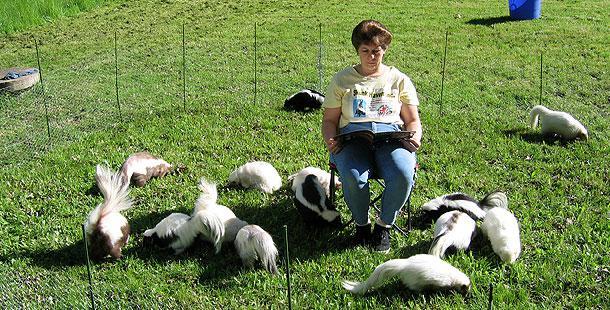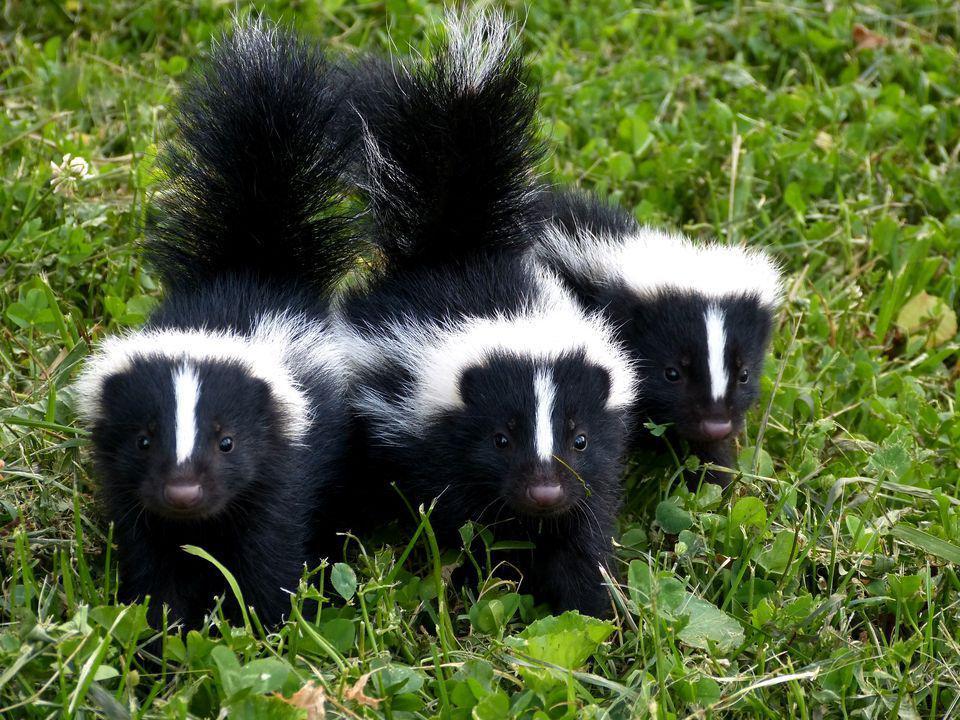The first image is the image on the left, the second image is the image on the right. Analyze the images presented: Is the assertion "At least one photo shows two or more skunks facing forward with their tails raised." valid? Answer yes or no. Yes. 